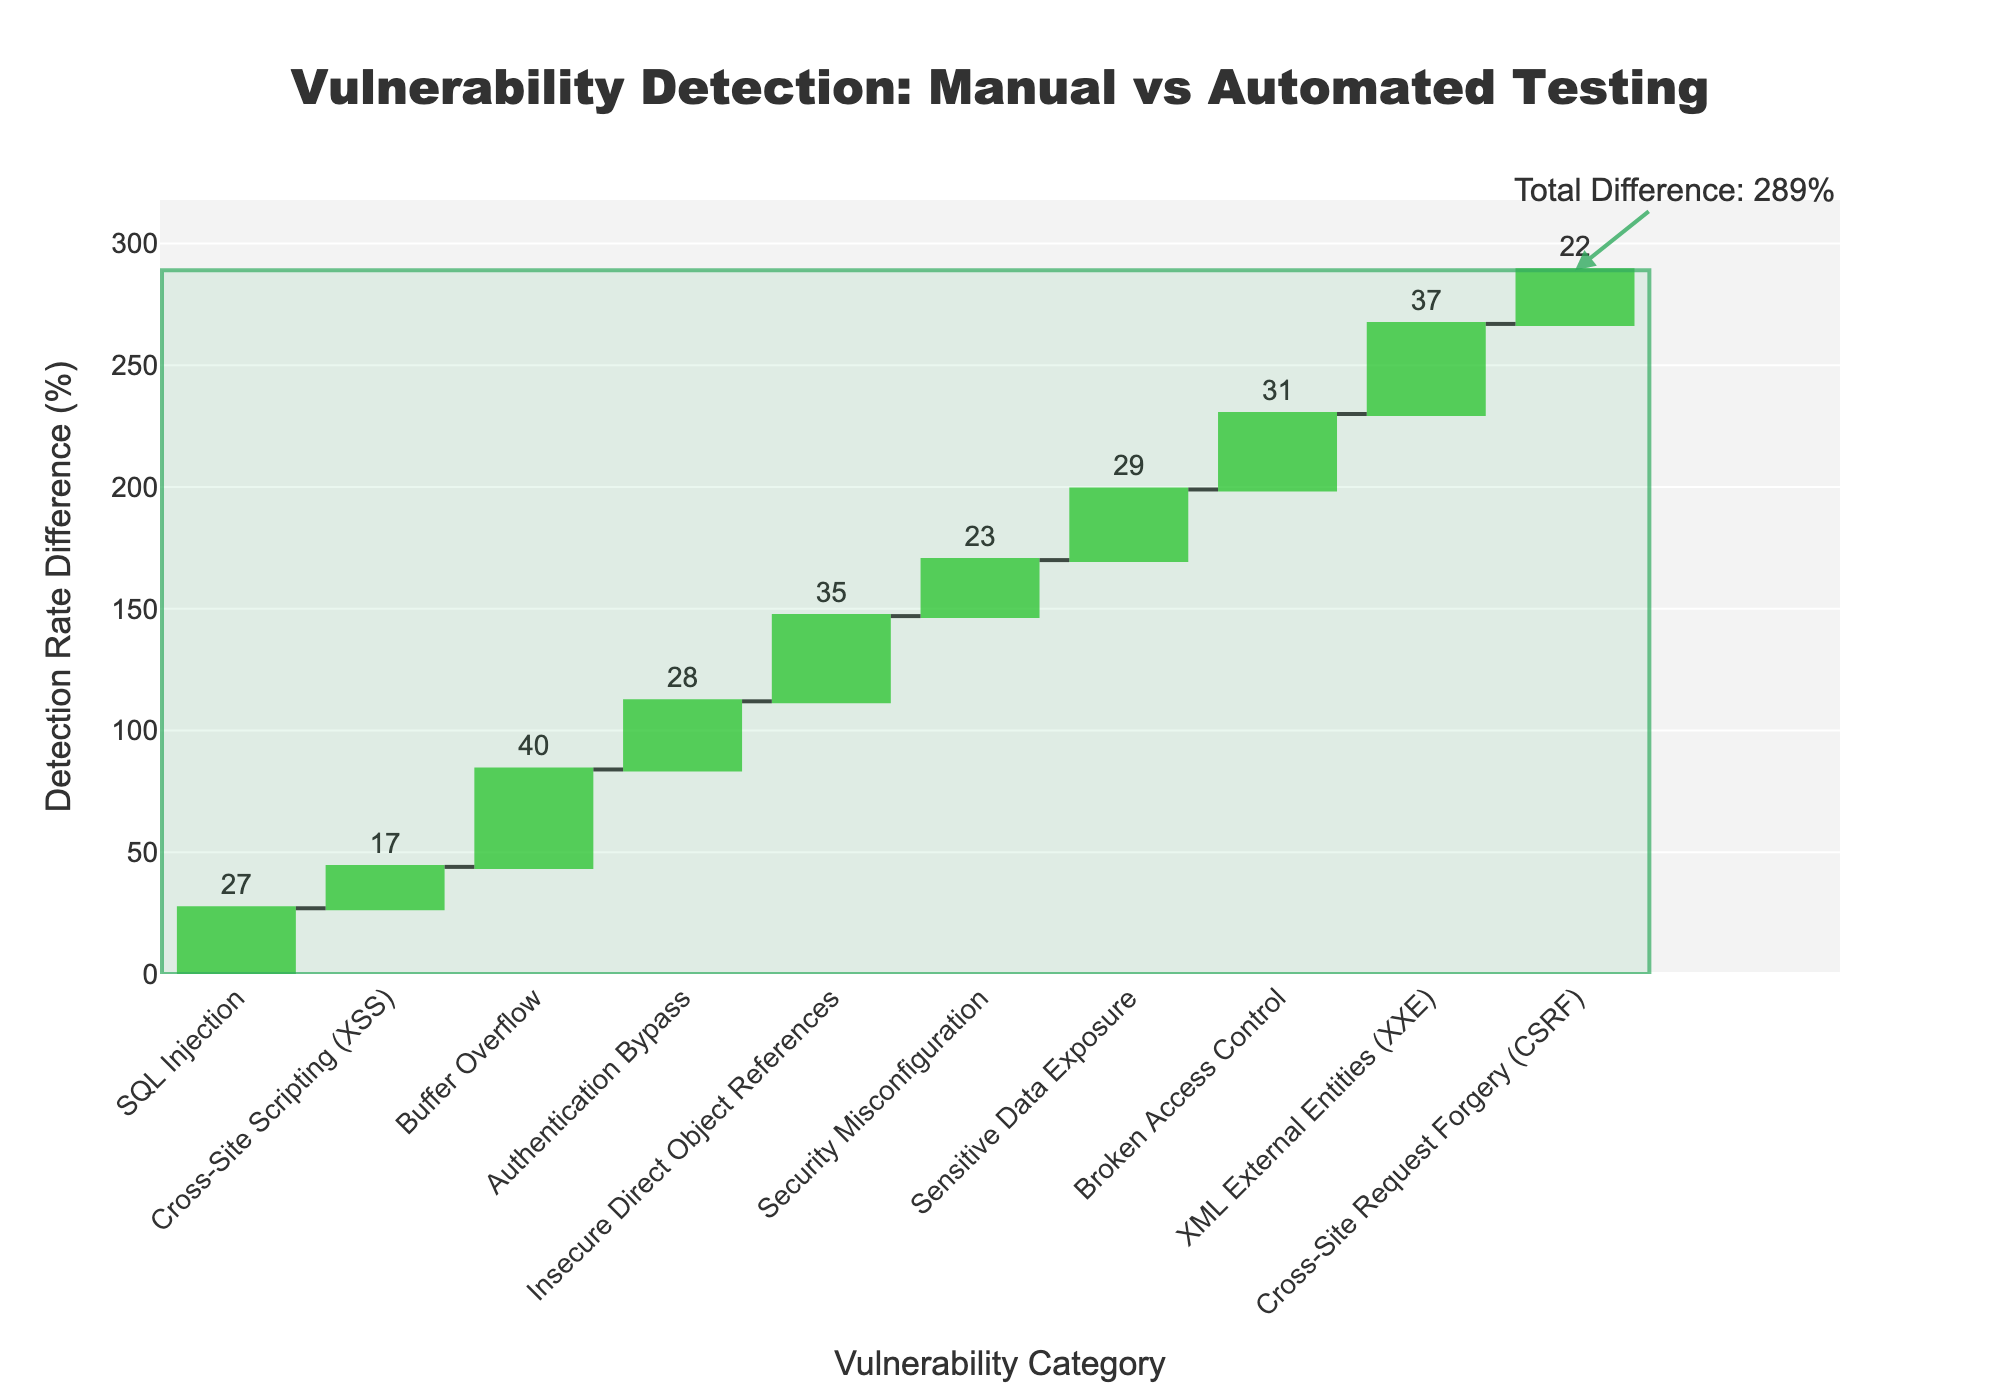What's the detected rate difference between SQL Injection and Cross-Site Scripting (XSS)? The chart shows the detected rate differences for each category. For SQL Injection, the difference is 27%, and for Cross-Site Scripting (XSS), it is 17%. Subtracting these, we get 27% - 17%.
Answer: 10% What is the total cumulative difference for all vulnerability types? The chart includes a total cumulative difference indicated at the end. The total cumulative difference is displayed as an annotation on the chart, stating "Total Difference: 289%".
Answer: 289% Which vulnerability type has the highest difference in detection rates between automated scans and manual penetration testing? Looking at the highest bar in the waterfall chart, Buffer Overflow has the largest height, indicating the highest difference. The hover text for Buffer Overflow also confirms this with a detected rate difference of 40%.
Answer: Buffer Overflow How does the manual detection rate for Broken Access Control compare to automated scans? The hover text or bar for Broken Access Control provides the detailed rates. Automated Scans detected 58%, whereas Manual Penetration Testing detected 89%, with a difference shown at 31%. Manual testing is higher by the difference value.
Answer: Manual testing is 31% higher What is the cumulative difference after accounting for the first five types of vulnerabilities? Summing the differences for the first five categories: SQL Injection (27%), Cross-Site Scripting (17%), Buffer Overflow (40%), Authentication Bypass (28%), and Insecure Direct Object References (35%) yields a total: 27 + 17 + 40 + 28 + 35 = 147%.
Answer: 147% Is Sensitive Data Exposure detected better through automated scans or manual penetration testing? The Sensitive Data Exposure bar shows a difference in detection rates. Hover text or bar indicates manual detection is higher than automated detection by 29% (manual 91%, automated 62%).
Answer: Manual testing is better Which vulnerability type has the lowest detection rate difference between the two methods? Observing the shortest bar in the waterfall chart points to Cross-Site Scripting (XSS) with a difference of 17%. The hover text for Cross-Site Scripting confirms the difference.
Answer: Cross-Site Scripting (XSS) What is the cumulative difference after Security Misconfiguration is accounted for? Adding the differences for all categories up to Security Misconfiguration: SQL Injection (27%), Cross-Site Scripting (17%), Buffer Overflow (40%), Authentication Bypass (28%), Insecure Direct Object References (35%), Security Misconfiguration (23%): 27 + 17 + 40 + 28 + 35 + 23 = 170%.
Answer: 170% What is the automated detection rate for Cross-Site Request Forgery (CSRF)? The hover text or the vertical bar for CSRF indicates the automated detection rate, which is 72%.
Answer: 72% What can we infer from the color code used in the bars of the waterfall chart? The color codes signify increases and decreases in the differences. Greenish tones indicate increasing positive differences (where manual is better), and reddish tones indicate drops (where automated might be higher, although none shown). All bars here are greenish, confirming manual is generally better.
Answer: Manual better (greenish tones) 